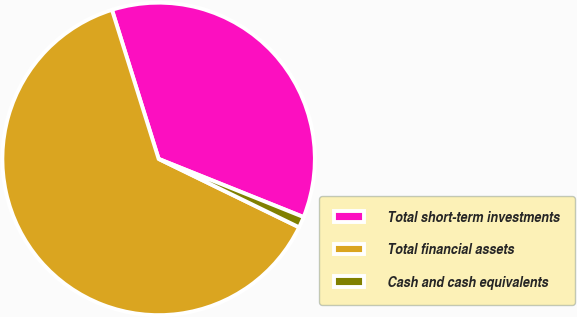<chart> <loc_0><loc_0><loc_500><loc_500><pie_chart><fcel>Total short-term investments<fcel>Total financial assets<fcel>Cash and cash equivalents<nl><fcel>35.9%<fcel>62.96%<fcel>1.14%<nl></chart> 